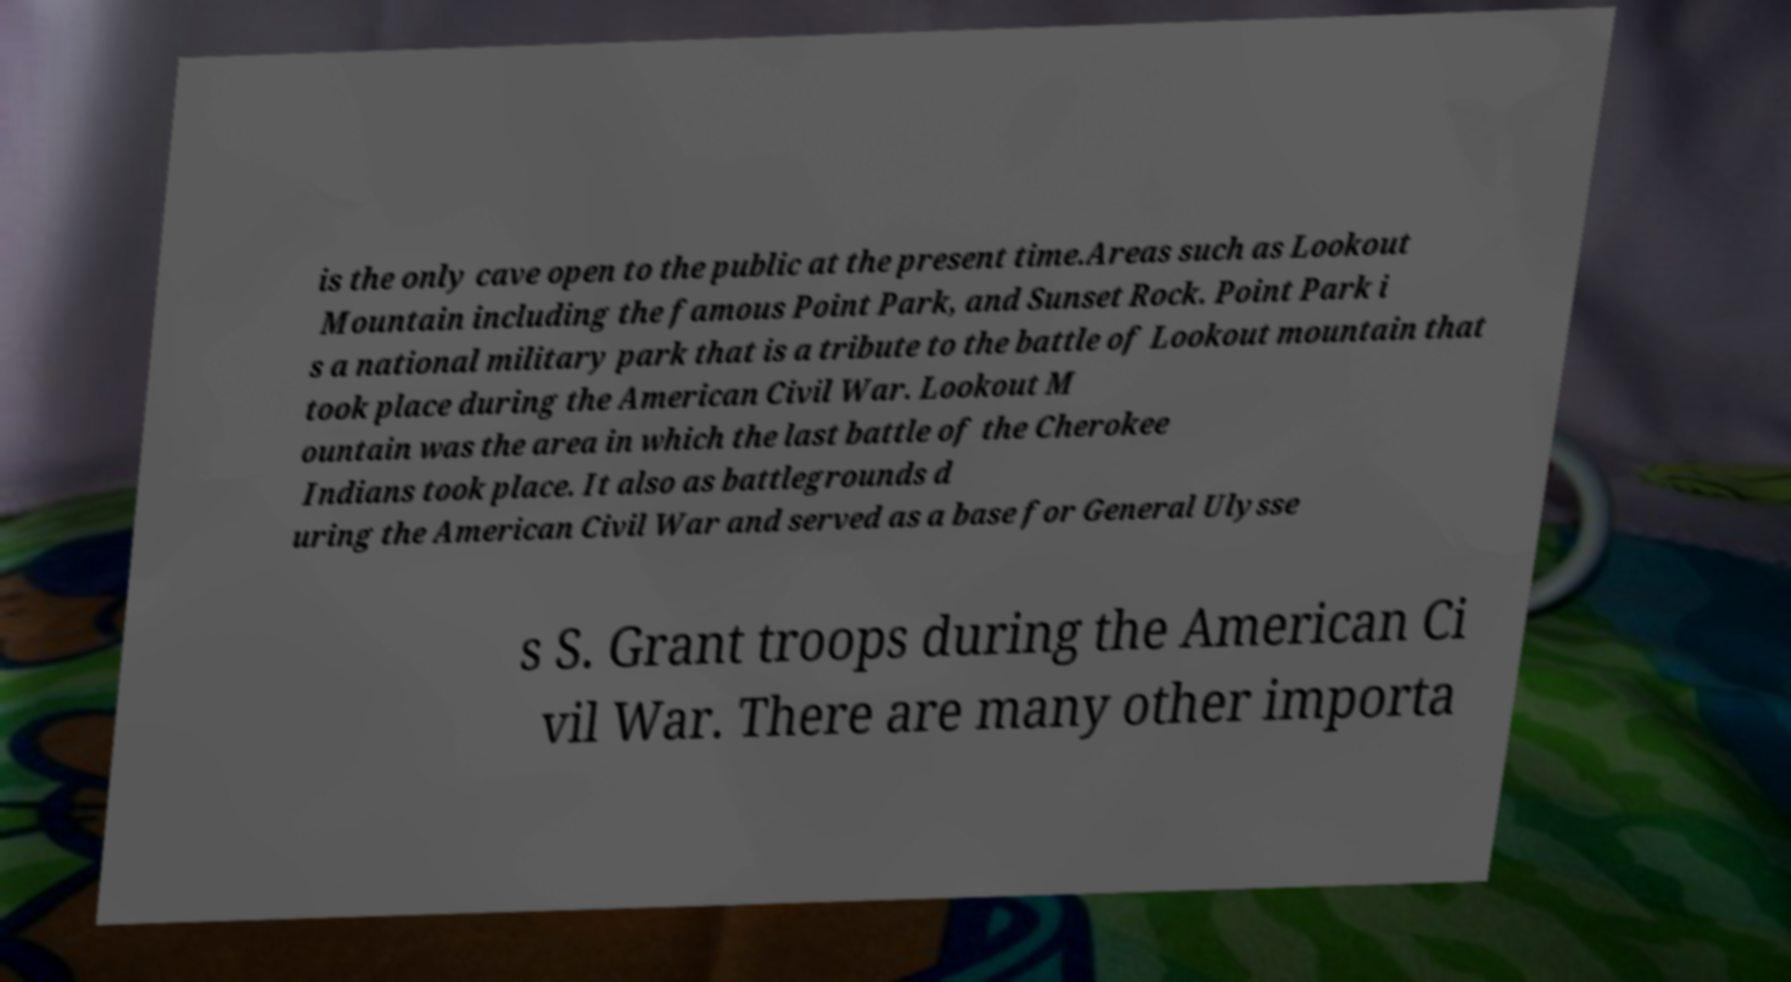Can you accurately transcribe the text from the provided image for me? is the only cave open to the public at the present time.Areas such as Lookout Mountain including the famous Point Park, and Sunset Rock. Point Park i s a national military park that is a tribute to the battle of Lookout mountain that took place during the American Civil War. Lookout M ountain was the area in which the last battle of the Cherokee Indians took place. It also as battlegrounds d uring the American Civil War and served as a base for General Ulysse s S. Grant troops during the American Ci vil War. There are many other importa 